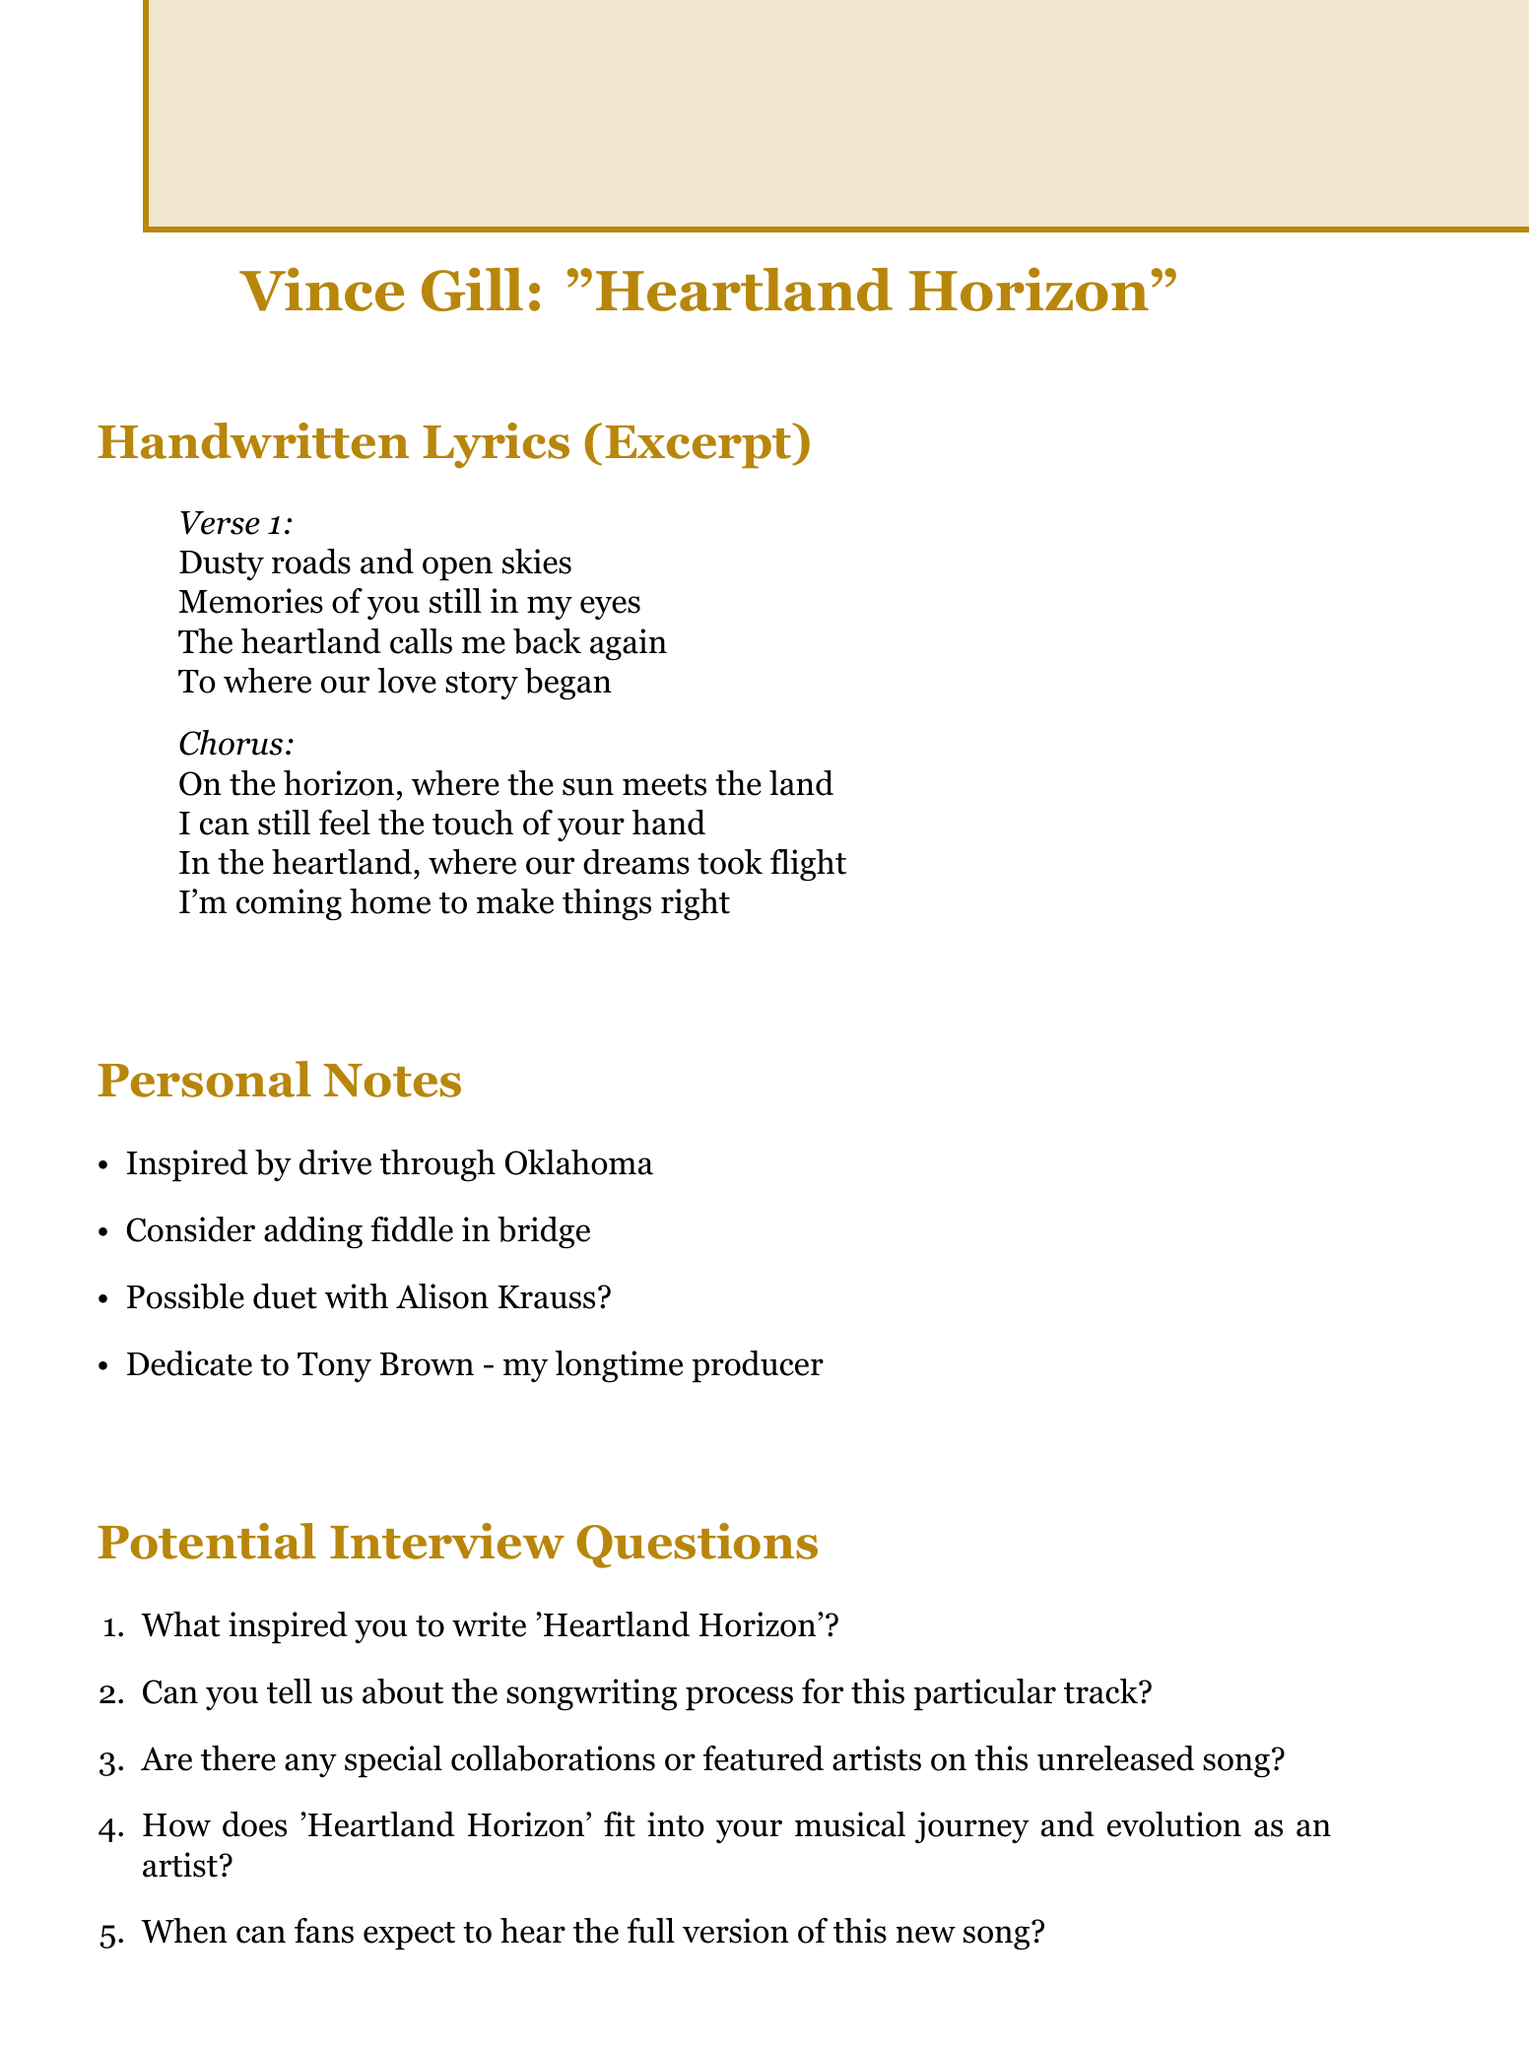What is the title of the song? The title of the song is explicitly stated in the document as "Heartland Horizon."
Answer: Heartland Horizon Who produced the song? The document lists Vince Gill and Justin Niebank as the producers of the song.
Answer: Vince Gill and Justin Niebank What is the expected release date? The document provides the expected release date as "Fall 2023."
Answer: Fall 2023 What instrument is being considered for the bridge? The document mentions a fiddle as an instrument that may be added in the bridge of the song.
Answer: Fiddle Who is the song dedicated to? According to the personal notes, the song is dedicated to Tony Brown, Vince Gill's longtime producer.
Answer: Tony Brown What inspired the song? The personal notes indicate that the song was inspired by a drive through Oklahoma.
Answer: Drive through Oklahoma What record label will release the song? The document specifies that MCA Nashville is the record label associated with the song.
Answer: MCA Nashville Who might collaborate on this song? The potential collaboration mentioned in the personal notes is with Alison Krauss.
Answer: Alison Krauss How does the song fit into Vince Gill's career? The document prompts inquiry into the song's role in Vince Gill's musical journey and evolution, indicating deeper significance.
Answer: Related to musical journey 